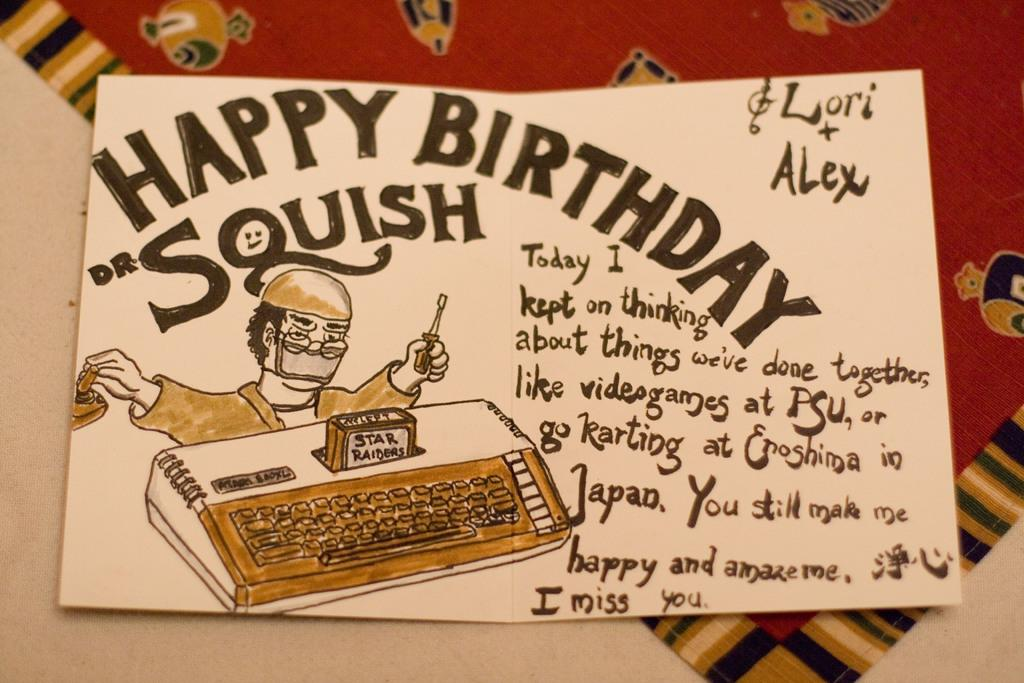<image>
Give a short and clear explanation of the subsequent image. A handmade card reading Happy Birthday Squish on it 